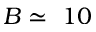<formula> <loc_0><loc_0><loc_500><loc_500>B \simeq \ 1 0</formula> 